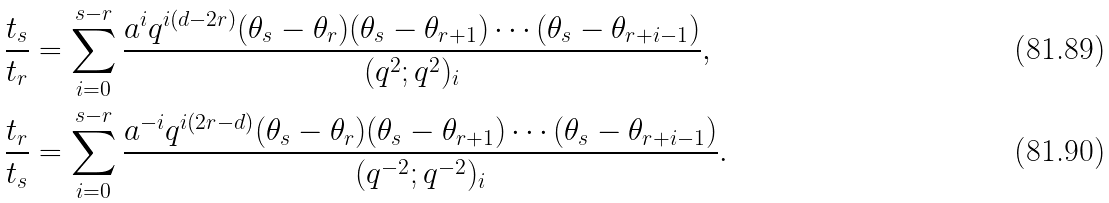<formula> <loc_0><loc_0><loc_500><loc_500>\frac { t _ { s } } { t _ { r } } & = \sum _ { i = 0 } ^ { s - r } \frac { a ^ { i } q ^ { i ( d - 2 r ) } ( \theta _ { s } - \theta _ { r } ) ( \theta _ { s } - \theta _ { r + 1 } ) \cdots ( \theta _ { s } - \theta _ { r + i - 1 } ) } { ( q ^ { 2 } ; q ^ { 2 } ) _ { i } } , \\ \frac { t _ { r } } { t _ { s } } & = \sum _ { i = 0 } ^ { s - r } \frac { a ^ { - i } q ^ { i ( 2 r - d ) } ( \theta _ { s } - \theta _ { r } ) ( \theta _ { s } - \theta _ { r + 1 } ) \cdots ( \theta _ { s } - \theta _ { r + i - 1 } ) } { ( q ^ { - 2 } ; q ^ { - 2 } ) _ { i } } .</formula> 